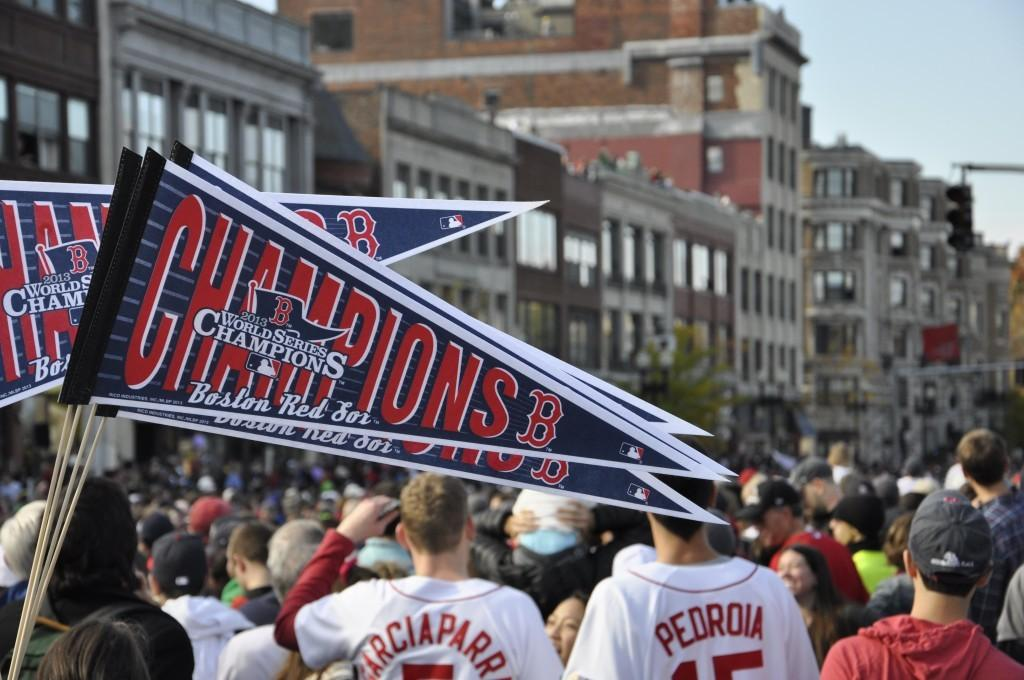<image>
Offer a succinct explanation of the picture presented. People holding mini flags that says Champions on it. 